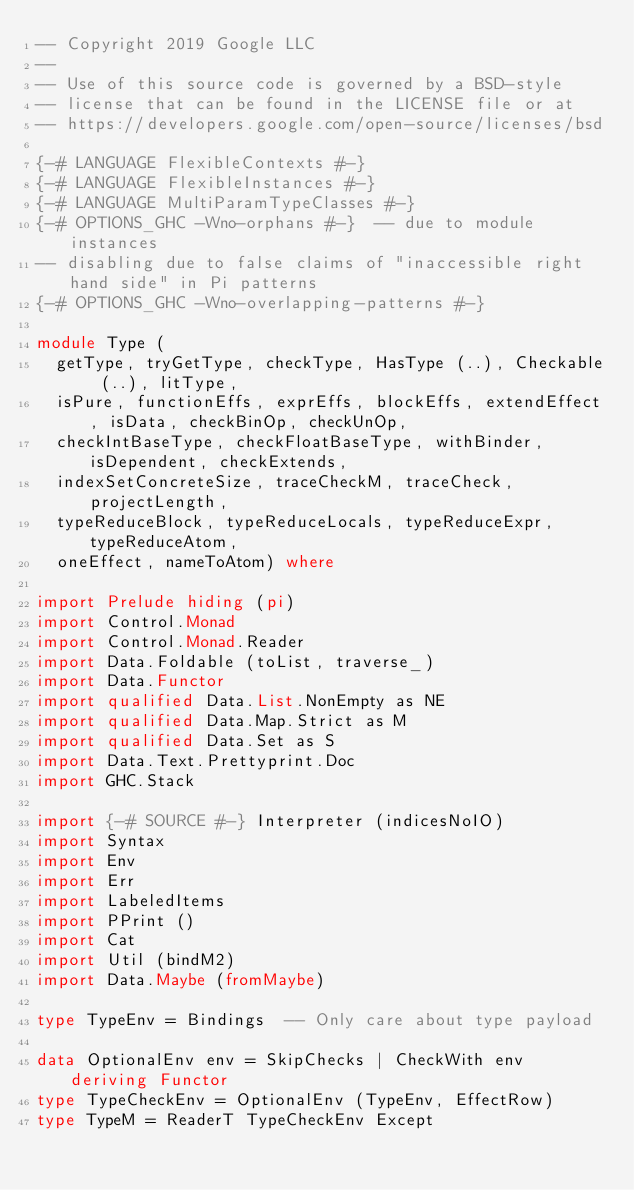Convert code to text. <code><loc_0><loc_0><loc_500><loc_500><_Haskell_>-- Copyright 2019 Google LLC
--
-- Use of this source code is governed by a BSD-style
-- license that can be found in the LICENSE file or at
-- https://developers.google.com/open-source/licenses/bsd

{-# LANGUAGE FlexibleContexts #-}
{-# LANGUAGE FlexibleInstances #-}
{-# LANGUAGE MultiParamTypeClasses #-}
{-# OPTIONS_GHC -Wno-orphans #-}  -- due to module instances
-- disabling due to false claims of "inaccessible right hand side" in Pi patterns
{-# OPTIONS_GHC -Wno-overlapping-patterns #-}

module Type (
  getType, tryGetType, checkType, HasType (..), Checkable (..), litType,
  isPure, functionEffs, exprEffs, blockEffs, extendEffect, isData, checkBinOp, checkUnOp,
  checkIntBaseType, checkFloatBaseType, withBinder, isDependent, checkExtends,
  indexSetConcreteSize, traceCheckM, traceCheck, projectLength,
  typeReduceBlock, typeReduceLocals, typeReduceExpr, typeReduceAtom,
  oneEffect, nameToAtom) where

import Prelude hiding (pi)
import Control.Monad
import Control.Monad.Reader
import Data.Foldable (toList, traverse_)
import Data.Functor
import qualified Data.List.NonEmpty as NE
import qualified Data.Map.Strict as M
import qualified Data.Set as S
import Data.Text.Prettyprint.Doc
import GHC.Stack

import {-# SOURCE #-} Interpreter (indicesNoIO)
import Syntax
import Env
import Err
import LabeledItems
import PPrint ()
import Cat
import Util (bindM2)
import Data.Maybe (fromMaybe)

type TypeEnv = Bindings  -- Only care about type payload

data OptionalEnv env = SkipChecks | CheckWith env  deriving Functor
type TypeCheckEnv = OptionalEnv (TypeEnv, EffectRow)
type TypeM = ReaderT TypeCheckEnv Except
</code> 